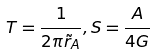<formula> <loc_0><loc_0><loc_500><loc_500>T = \frac { 1 } { 2 \pi \tilde { r } _ { A } } , S = \frac { A } { 4 G }</formula> 